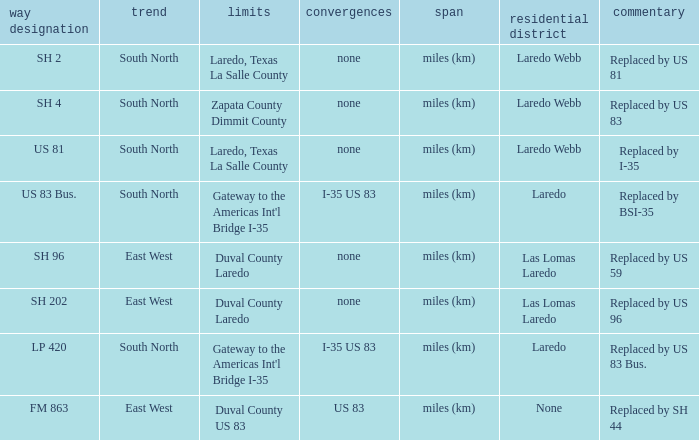How many termini are there that have "east west" listed in their direction section, "none" listed in their junction section, and have a route name of "sh 202"? 1.0. 